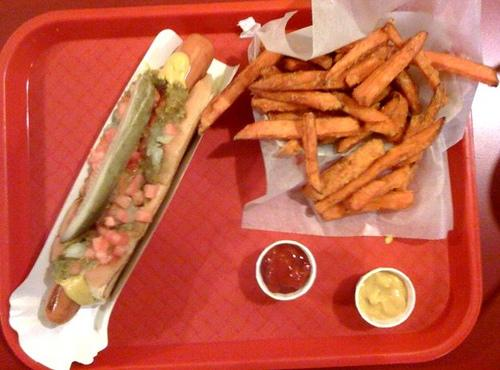What is on the left of the tray?

Choices:
A) fish
B) hot dog
C) hamburger
D) bagel hot dog 